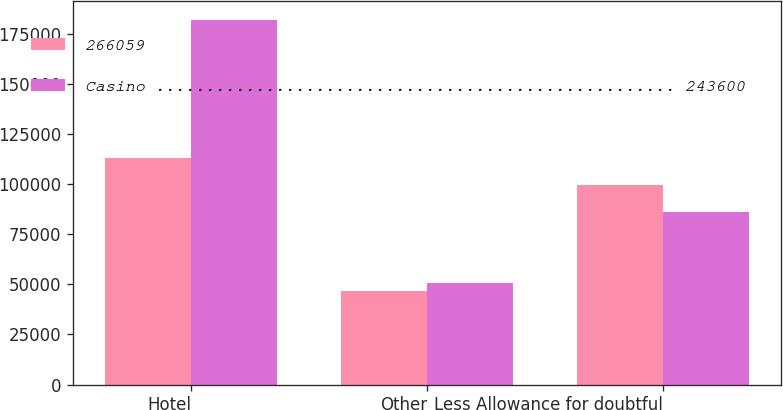Convert chart to OTSL. <chart><loc_0><loc_0><loc_500><loc_500><stacked_bar_chart><ecel><fcel>Hotel<fcel>Other<fcel>Less Allowance for doubtful<nl><fcel>266059<fcel>112985<fcel>46437<fcel>99606<nl><fcel>Casino .................................................... 243600<fcel>181983<fcel>50815<fcel>85924<nl></chart> 